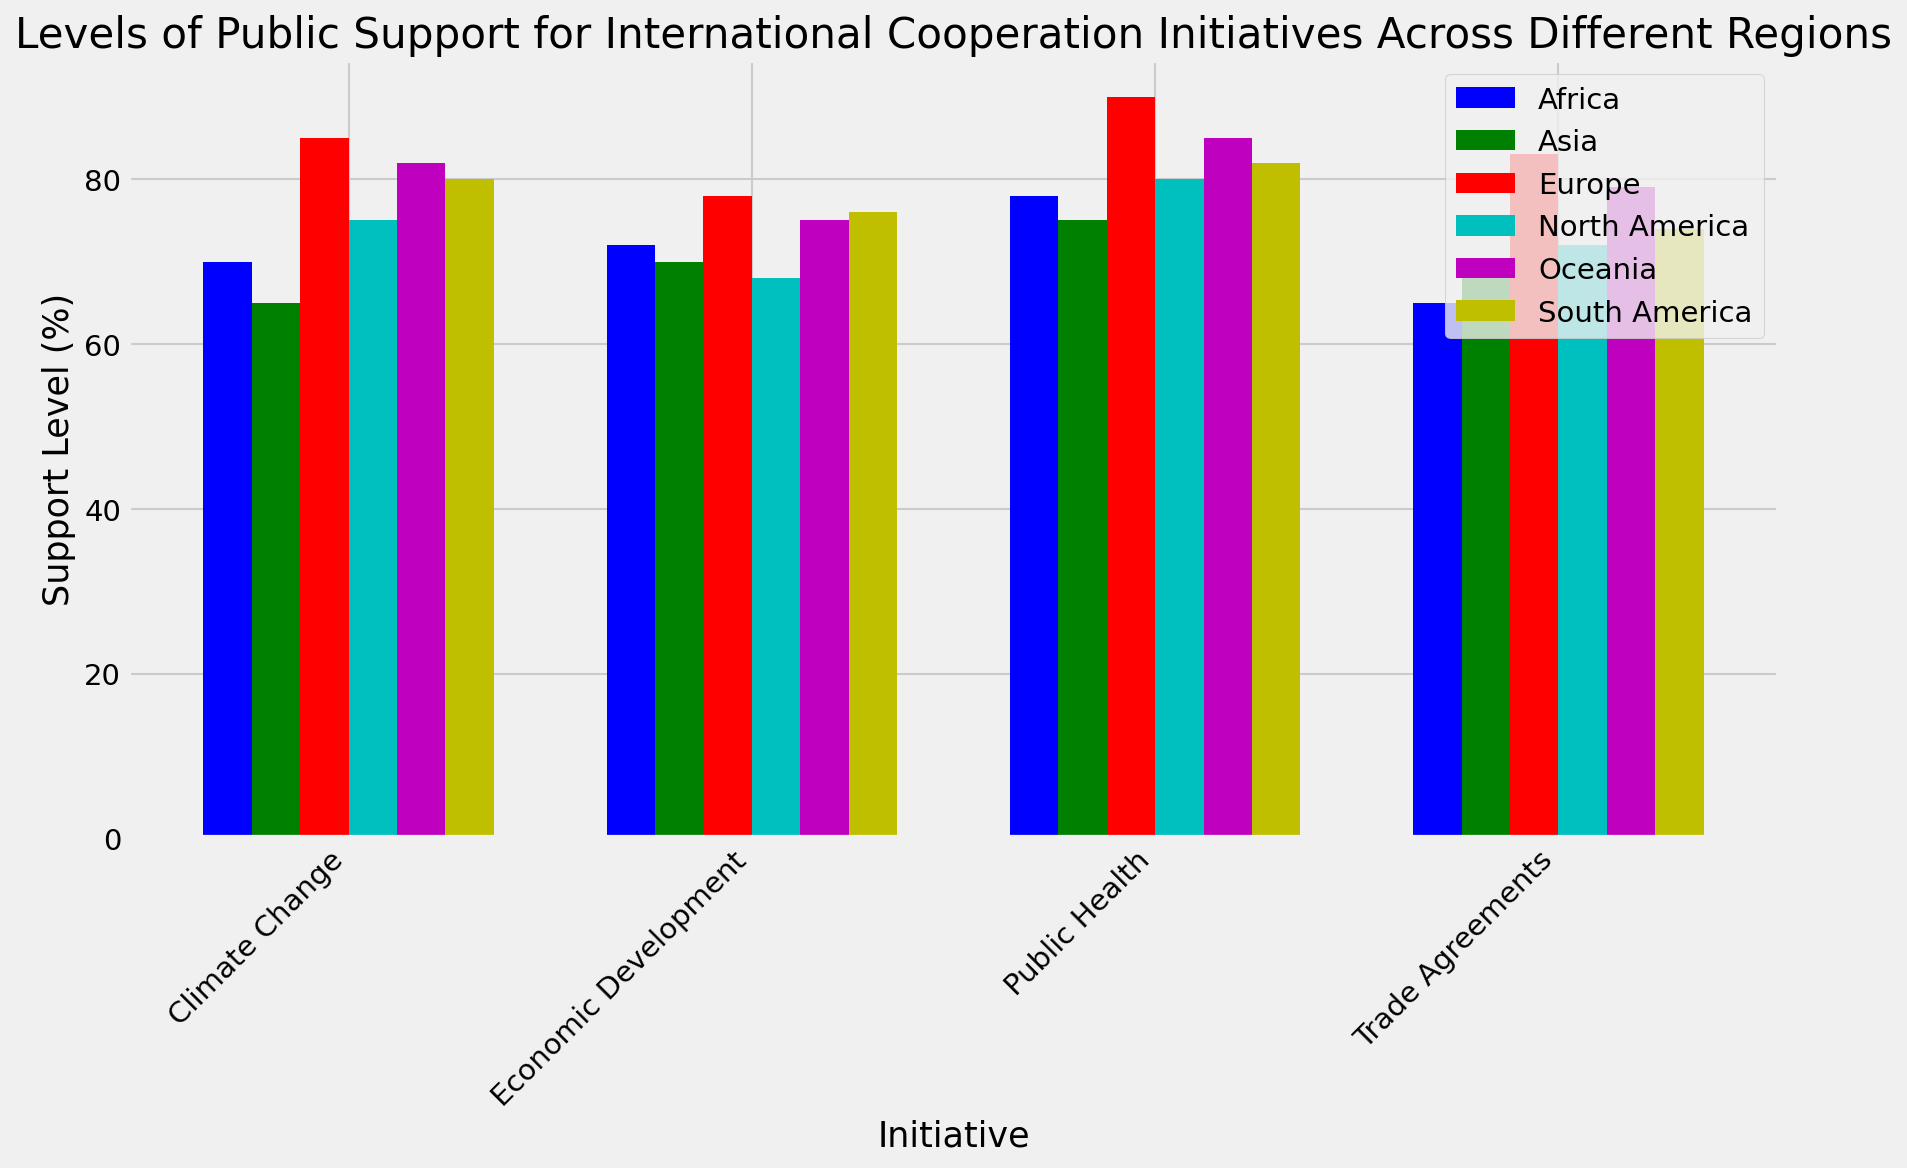Which region has the highest level of public support for cooperation on public health initiatives? To determine this, look at the bars representing public health initiatives across different regions and identify the tallest bar. The tallest bar belongs to Europe with a support level of 90%.
Answer: Europe Which initiative has the lowest level of public support in Africa? Look at the bars corresponding to Africa and find the smallest bar among the four initiatives. The smallest bar represents trade agreements with a support level of 65%.
Answer: Trade Agreements On average, how does the public support for economic development initiatives compare between North America and South America? Calculate the average support level by adding the support percentages for economic development initiatives in North America and South America and dividing by two. North America has 68%, and South America has 76%. The average is (68 + 76) / 2 = 72%.
Answer: 72% Rank the regions from highest to lowest support levels for climate change initiatives. Compare the bars corresponding to climate change initiatives across all regions: Europe (85%), Oceania (82%), South America (80%), North America (75%), Africa (70%), and Asia (65%).
Answer: Europe, Oceania, South America, North America, Africa, Asia How does public support for trade agreements in Oceania compare to support for the same initiative in Europe? Look at the bars corresponding to trade agreements in Oceania and Europe. Oceania's bar is at 79%, and Europe's bar is at 83%. Oceania has slightly less support than Europe.
Answer: Less Which initiative has the most uniform levels of public support across all regions? Evaluate the variation in bar heights for each initiative across all regions. Economic Development shows a relatively uniform level of support with values close to each other (68, 78, 70, 76, 72, 75).
Answer: Economic Development What is the difference in public support for climate change initiatives between North America and Asia? Subtract Asia's support level (65%) from North America's support level (75%). The difference is 75% - 65% = 10%.
Answer: 10% Compare the support levels for public health initiatives in North America and Oceania. Look at the bars for public health in North America (80%) and Oceania (85%). Oceania has a higher support level by 5%.
Answer: Oceania What is the total public support for trade agreements across all regions? Add the support percentages for trade agreements across all regions: 72% (North America) + 83% (Europe) + 68% (Asia) + 74% (South America) + 65% (Africa) + 79% (Oceania). The total is 72 + 83 + 68 + 74 + 65 + 79 = 441%.
Answer: 441% 